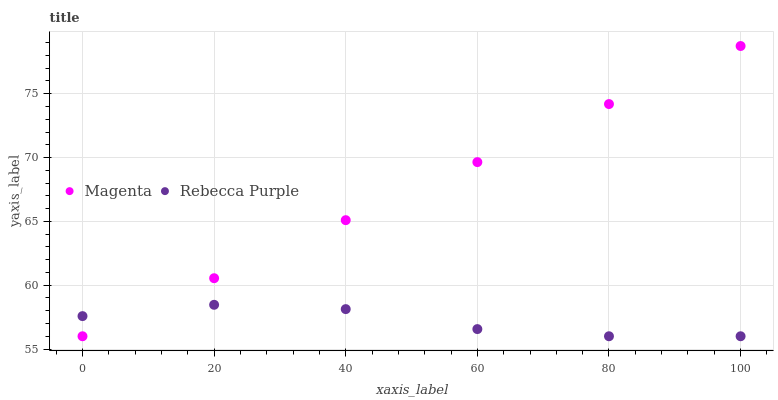Does Rebecca Purple have the minimum area under the curve?
Answer yes or no. Yes. Does Magenta have the maximum area under the curve?
Answer yes or no. Yes. Does Rebecca Purple have the maximum area under the curve?
Answer yes or no. No. Is Magenta the smoothest?
Answer yes or no. Yes. Is Rebecca Purple the roughest?
Answer yes or no. Yes. Is Rebecca Purple the smoothest?
Answer yes or no. No. Does Magenta have the lowest value?
Answer yes or no. Yes. Does Magenta have the highest value?
Answer yes or no. Yes. Does Rebecca Purple have the highest value?
Answer yes or no. No. Does Rebecca Purple intersect Magenta?
Answer yes or no. Yes. Is Rebecca Purple less than Magenta?
Answer yes or no. No. Is Rebecca Purple greater than Magenta?
Answer yes or no. No. 